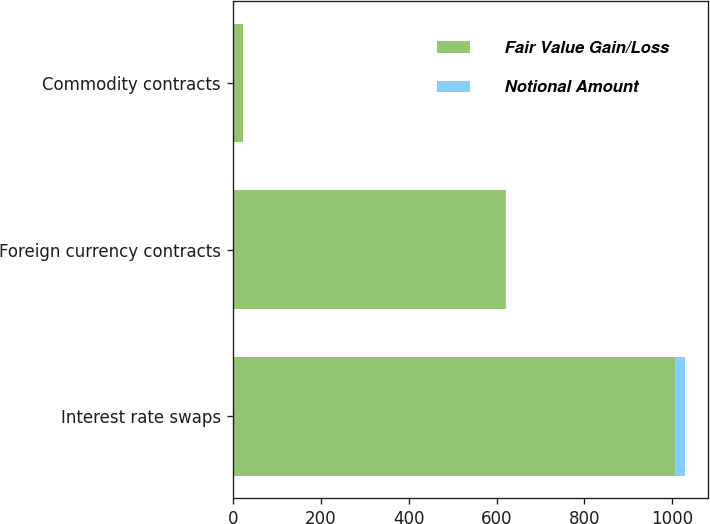Convert chart. <chart><loc_0><loc_0><loc_500><loc_500><stacked_bar_chart><ecel><fcel>Interest rate swaps<fcel>Foreign currency contracts<fcel>Commodity contracts<nl><fcel>Fair Value Gain/Loss<fcel>1006<fcel>618.3<fcel>24.2<nl><fcel>Notional Amount<fcel>23.4<fcel>2.8<fcel>0<nl></chart> 